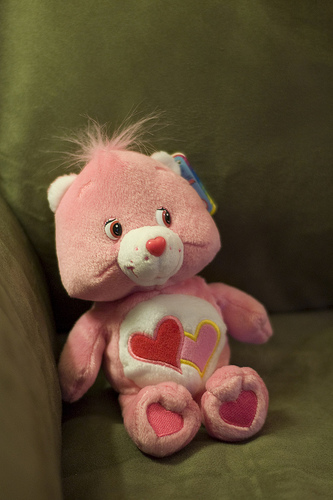<image>
Is the toy behind the chair? No. The toy is not behind the chair. From this viewpoint, the toy appears to be positioned elsewhere in the scene. Where is the animal in relation to the sofa? Is it on the sofa? Yes. Looking at the image, I can see the animal is positioned on top of the sofa, with the sofa providing support. 